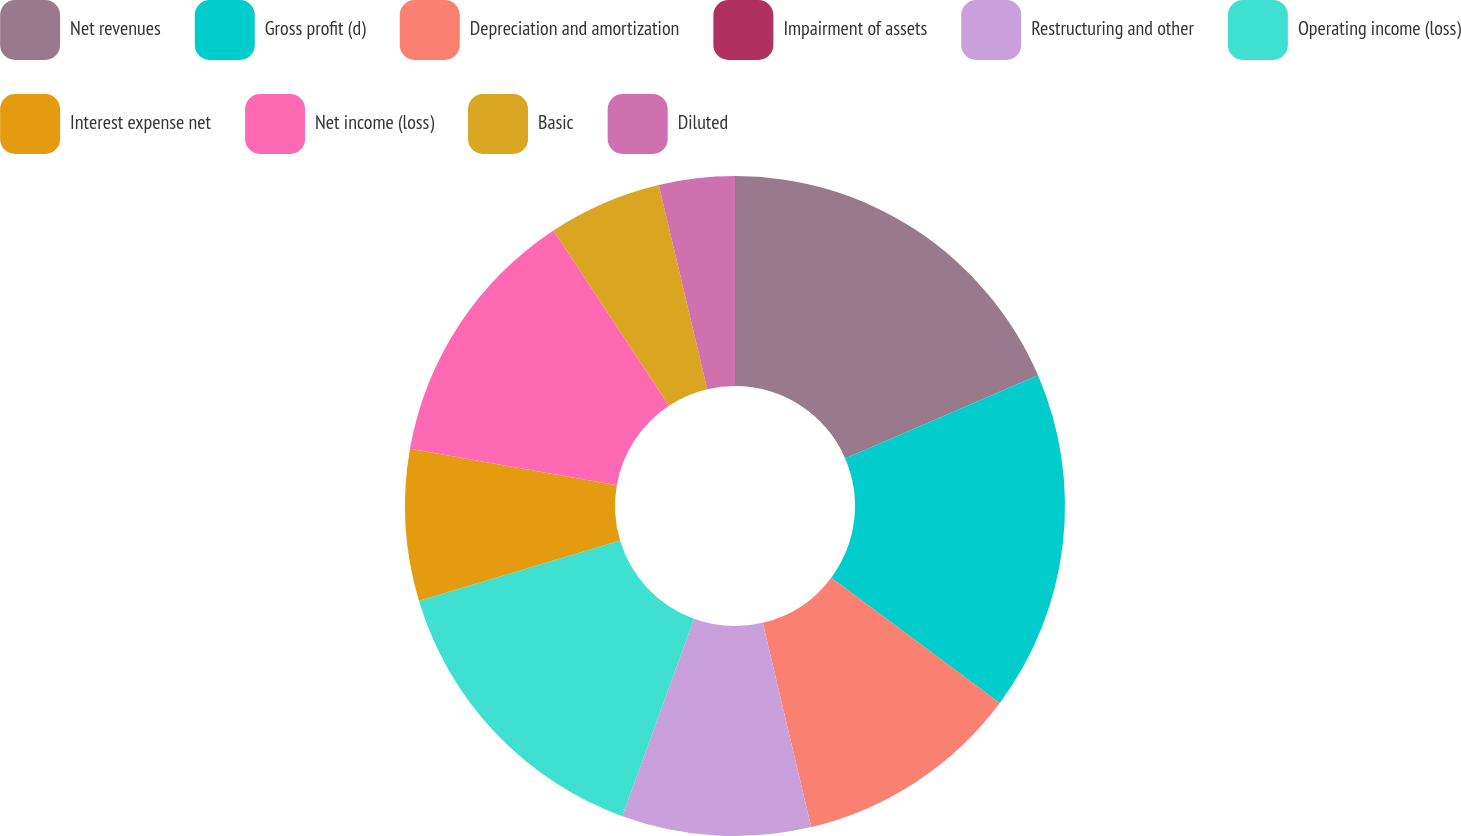Convert chart to OTSL. <chart><loc_0><loc_0><loc_500><loc_500><pie_chart><fcel>Net revenues<fcel>Gross profit (d)<fcel>Depreciation and amortization<fcel>Impairment of assets<fcel>Restructuring and other<fcel>Operating income (loss)<fcel>Interest expense net<fcel>Net income (loss)<fcel>Basic<fcel>Diluted<nl><fcel>18.52%<fcel>16.66%<fcel>11.11%<fcel>0.0%<fcel>9.26%<fcel>14.81%<fcel>7.41%<fcel>12.96%<fcel>5.56%<fcel>3.71%<nl></chart> 